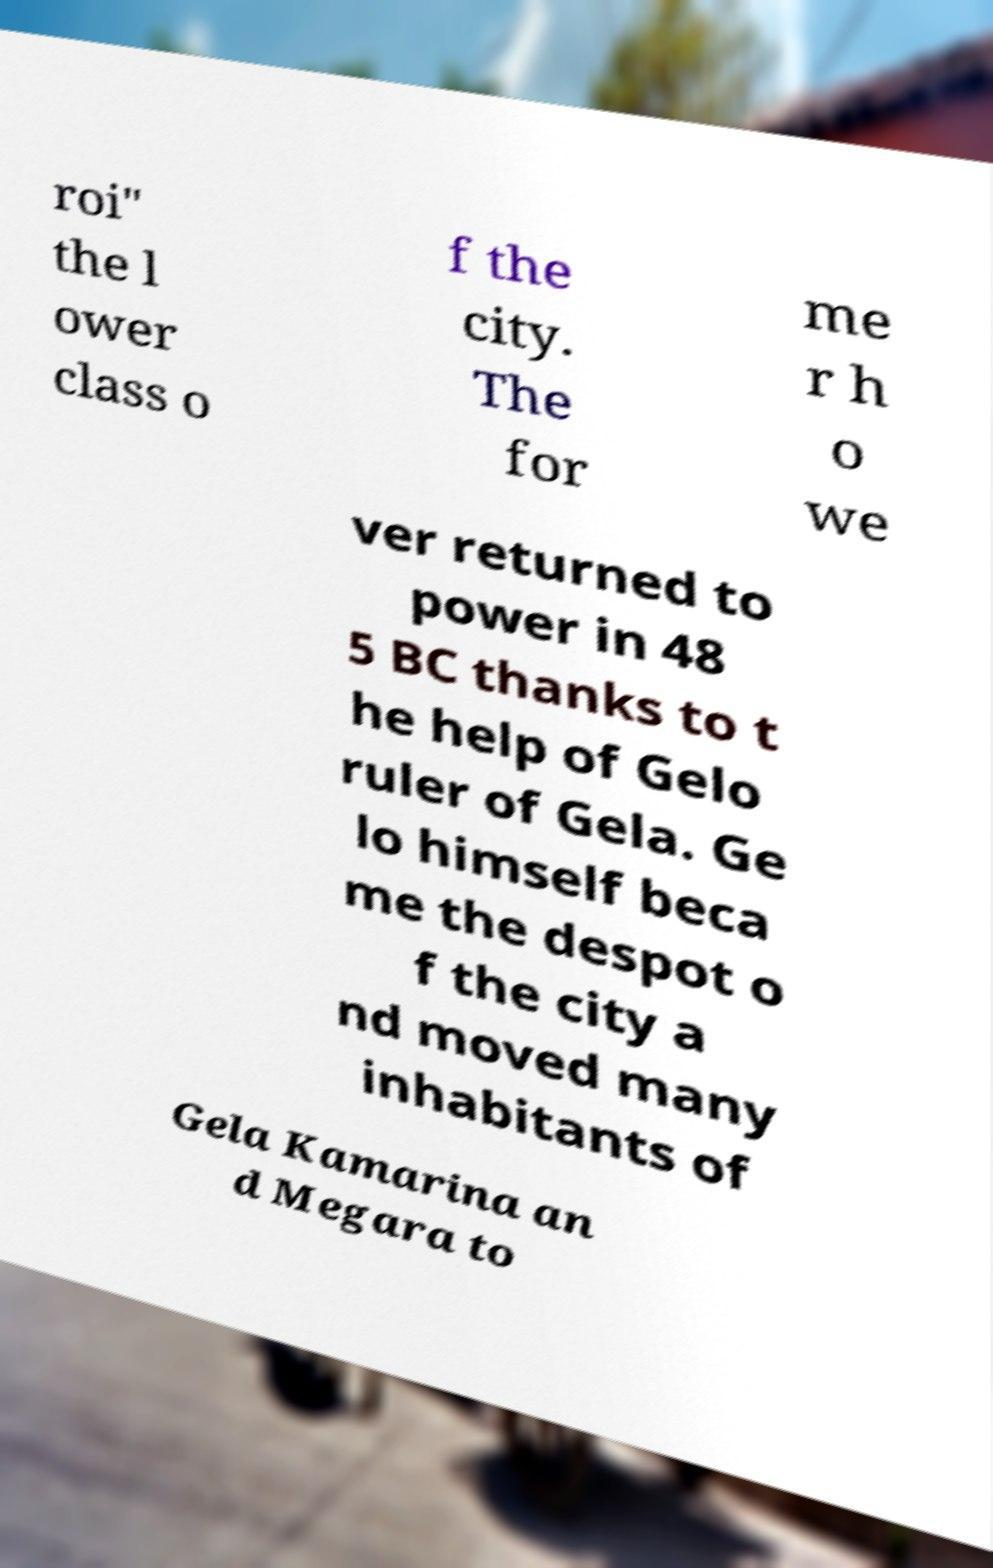For documentation purposes, I need the text within this image transcribed. Could you provide that? roi" the l ower class o f the city. The for me r h o we ver returned to power in 48 5 BC thanks to t he help of Gelo ruler of Gela. Ge lo himself beca me the despot o f the city a nd moved many inhabitants of Gela Kamarina an d Megara to 